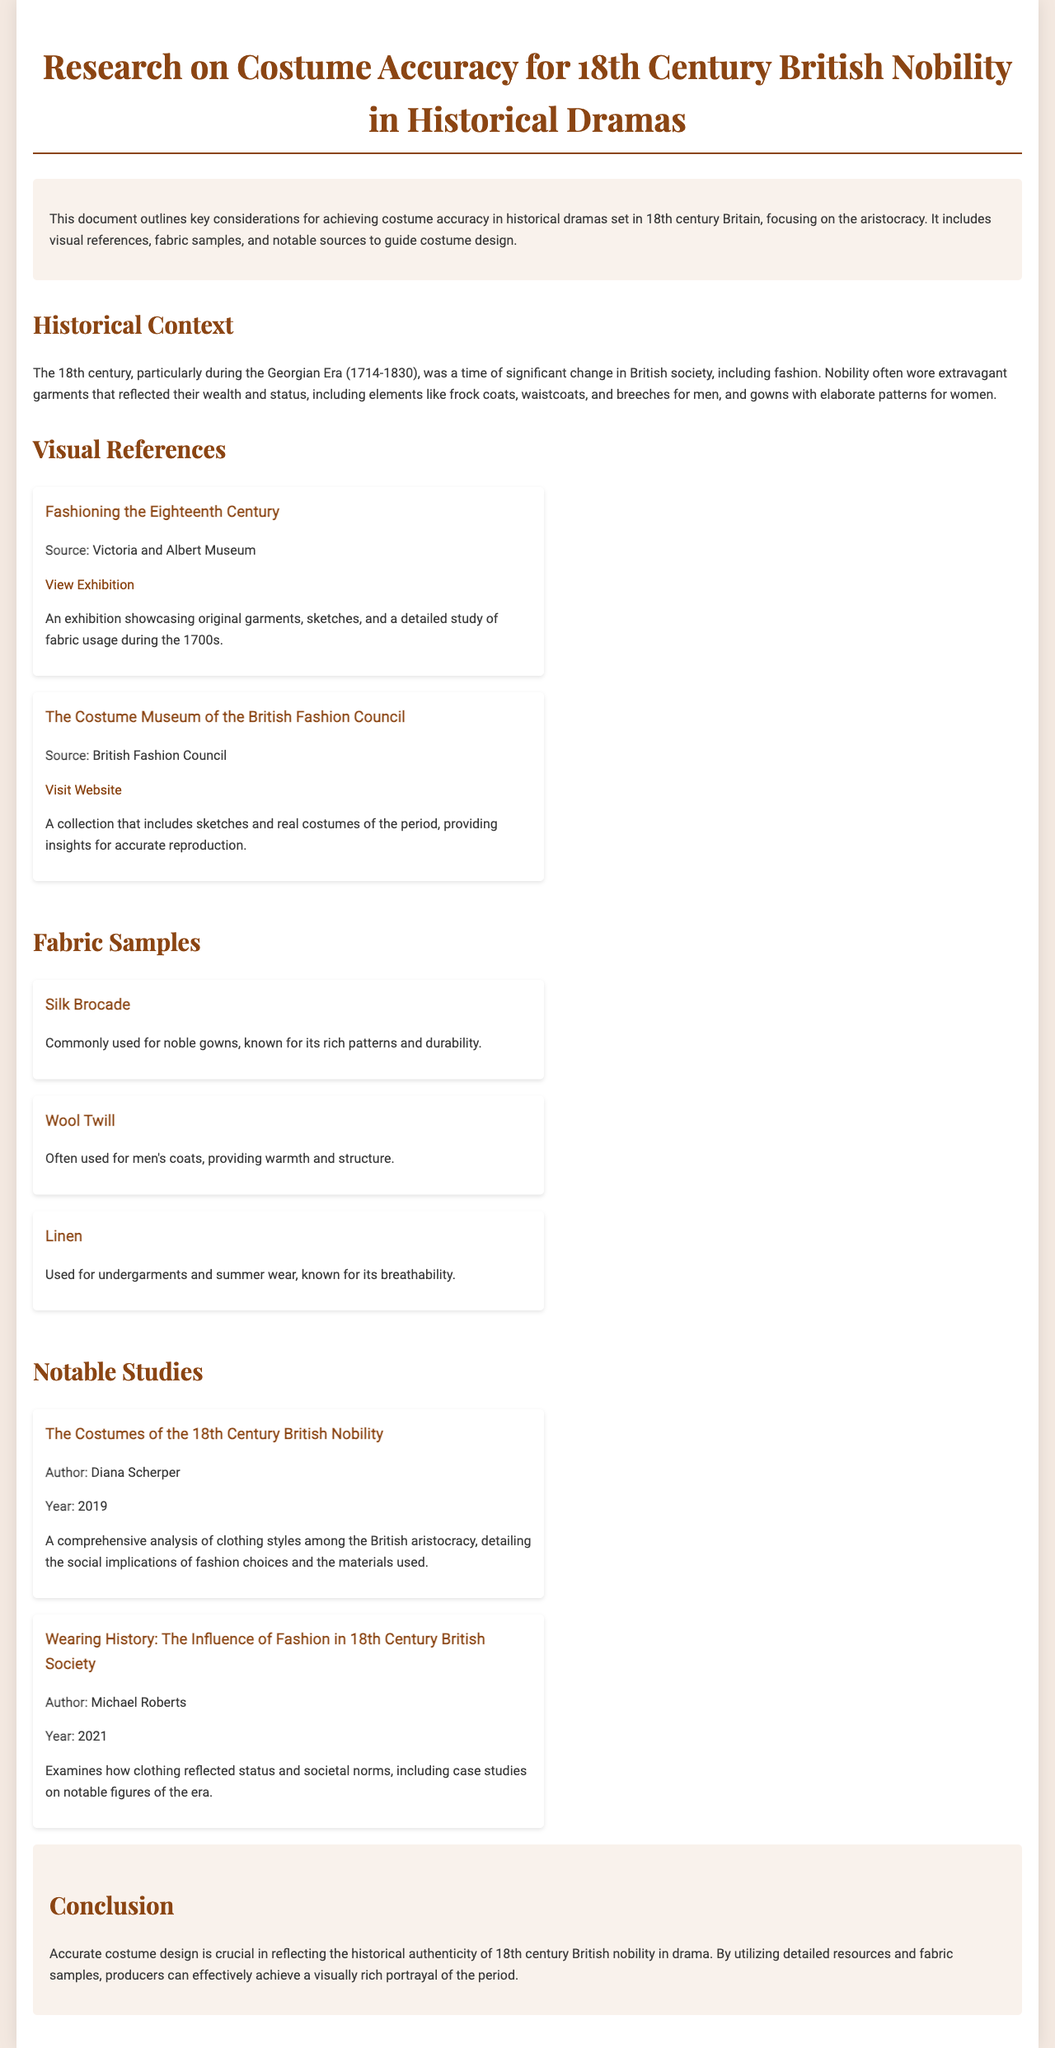What is the title of the document? The title of the document is prominently displayed at the top and summarizes the content regarding costume accuracy for 18th century British nobility.
Answer: Research on Costume Accuracy for 18th Century British Nobility in Historical Dramas What museum is referenced for visual references? The document mentions a specific exhibition that is hosted by a museum, providing insights into 18th century fashion.
Answer: Victoria and Albert Museum How many fabric samples are listed in the document? The document lists specific fabric types used in 18th century costumes, totaling three distinct samples assessed for accuracy.
Answer: Three Who is the author of the study titled "Wearing History: The Influence of Fashion in 18th Century British Society"? The document provides authorship information for multiple notable studies to aid research, highlighting one specific author for the mentioned study.
Answer: Michael Roberts What type of fabric is described as commonly used for noble gowns? The document provides details about various fabrics, detailing the prominent fabric type used in aristocratic gowns of the time period.
Answer: Silk Brocade What year was the study "The Costumes of the 18th Century British Nobility" published? The document specifies the release year of a significant analysis, helping contextualize the research within the timeline of historical studies.
Answer: 2019 What is emphasized as crucial in the conclusion of the document? The conclusion synthesizes key themes discussed earlier in the report, stating a vital aspect of costume design in historical dramas.
Answer: Accurate costume design What specific era does the document focus on regarding costume accuracy? The introduction highlights a particular time frame and its relevance to costume and fashion within historical settings, giving context to the research.
Answer: Georgian Era (1714-1830) 